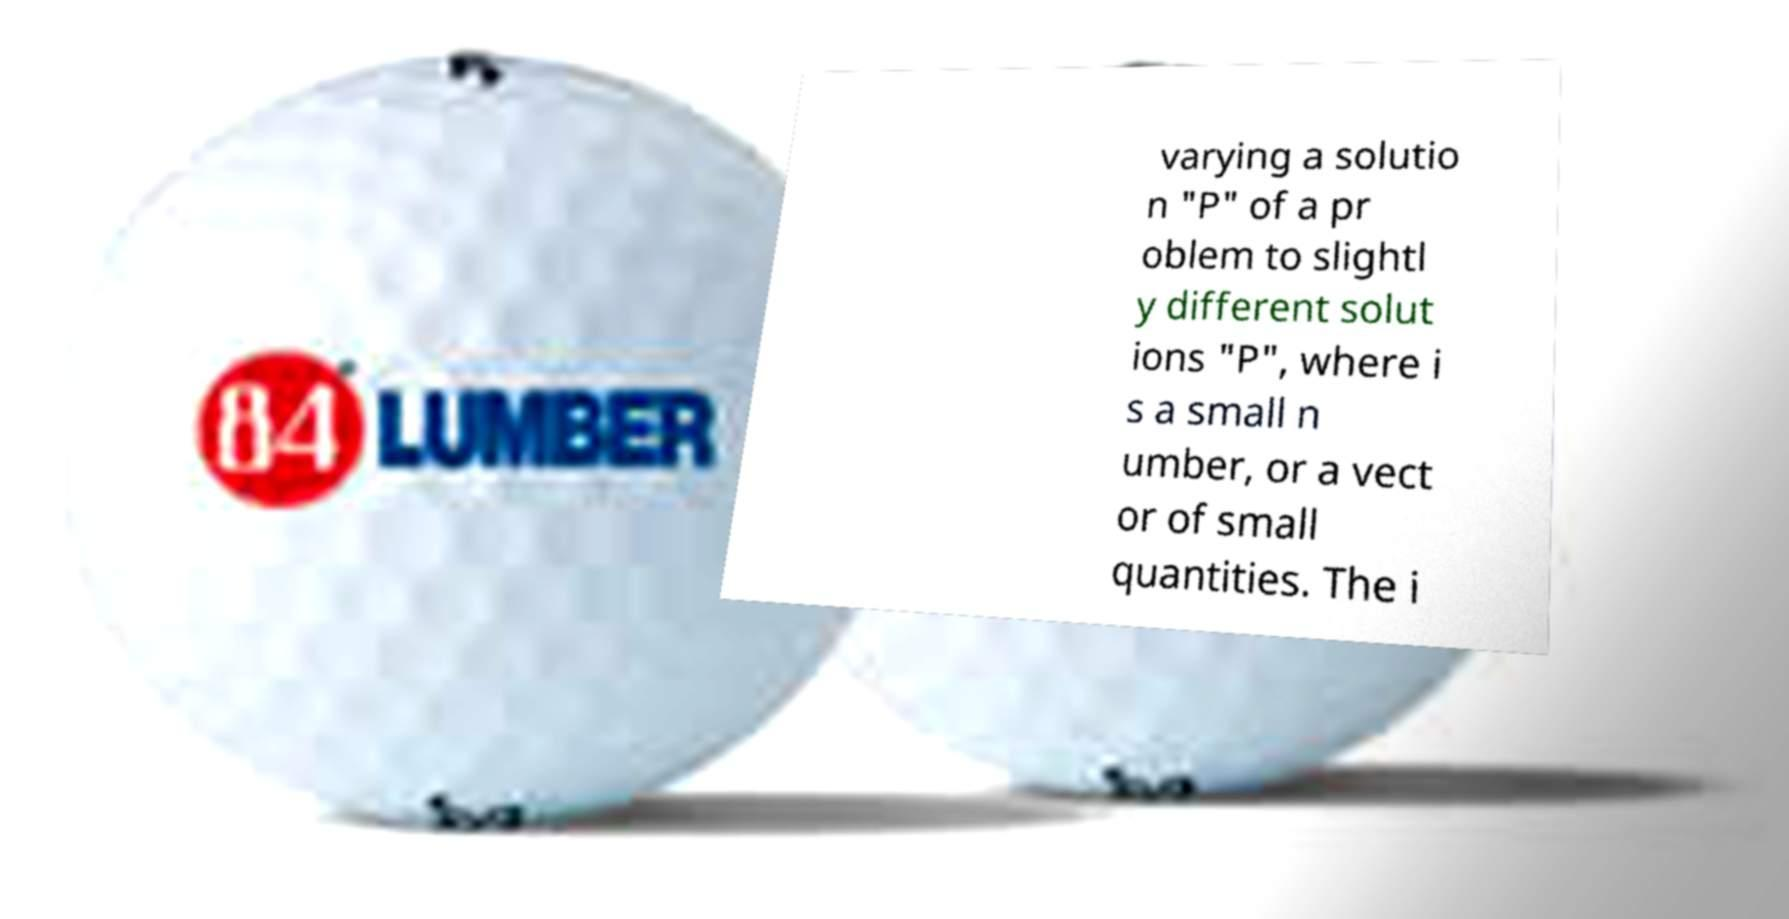For documentation purposes, I need the text within this image transcribed. Could you provide that? varying a solutio n "P" of a pr oblem to slightl y different solut ions "P", where i s a small n umber, or a vect or of small quantities. The i 